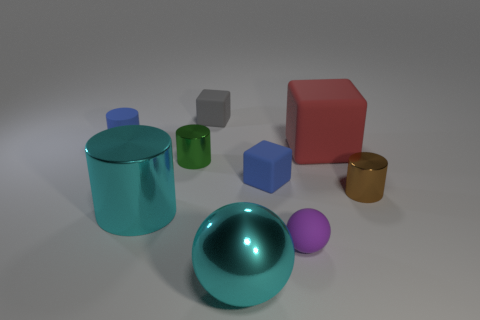Subtract all large rubber cubes. How many cubes are left? 2 Subtract 2 cylinders. How many cylinders are left? 2 Subtract all green cylinders. How many cylinders are left? 3 Add 1 big gray rubber cylinders. How many objects exist? 10 Subtract all balls. How many objects are left? 7 Subtract all yellow objects. Subtract all blue rubber cubes. How many objects are left? 8 Add 4 tiny shiny things. How many tiny shiny things are left? 6 Add 2 small green cylinders. How many small green cylinders exist? 3 Subtract 1 red cubes. How many objects are left? 8 Subtract all blue cylinders. Subtract all gray balls. How many cylinders are left? 3 